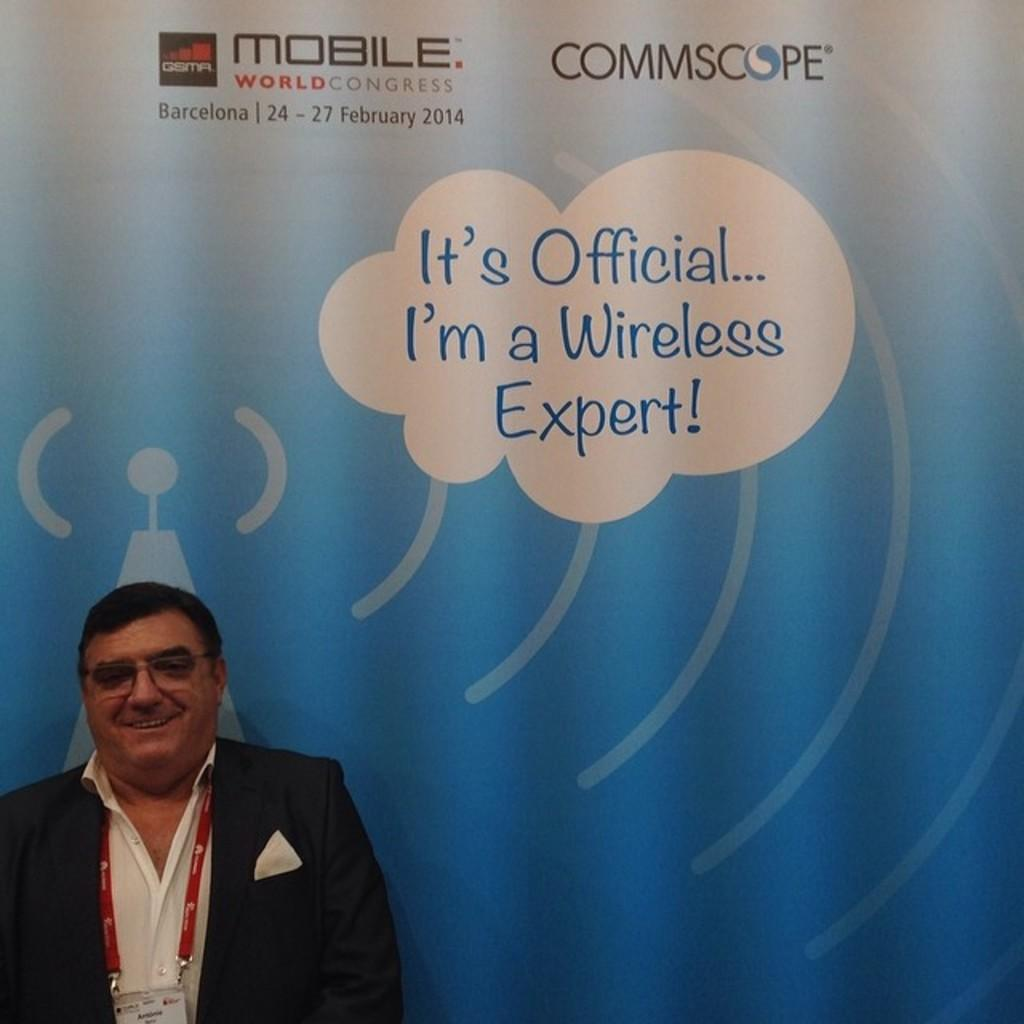<image>
Provide a brief description of the given image. The man smiling may be claiming to be a wireless expert. 